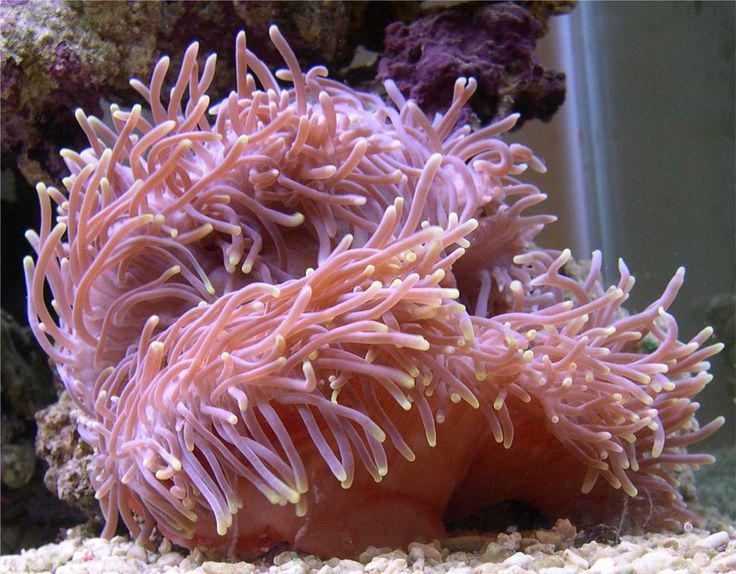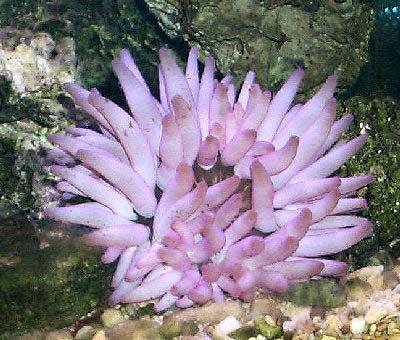The first image is the image on the left, the second image is the image on the right. Assess this claim about the two images: "Looking down from the top angle, into the colorful anemone pictured in the image on the right, reveals a central, mouth-like opening, surrounded by tentacles.". Correct or not? Answer yes or no. No. The first image is the image on the left, the second image is the image on the right. Evaluate the accuracy of this statement regarding the images: "In at least one image, there are at least different two types of coral with the base color pink or white.". Is it true? Answer yes or no. No. 